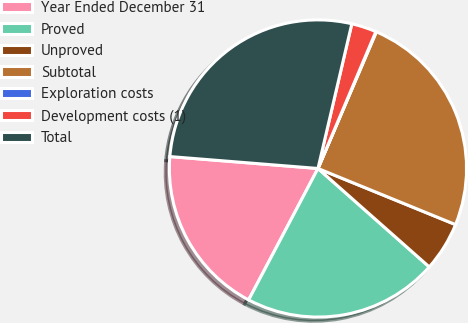<chart> <loc_0><loc_0><loc_500><loc_500><pie_chart><fcel>Year Ended December 31<fcel>Proved<fcel>Unproved<fcel>Subtotal<fcel>Exploration costs<fcel>Development costs (1)<fcel>Total<nl><fcel>18.55%<fcel>21.2%<fcel>5.36%<fcel>24.74%<fcel>0.06%<fcel>2.71%<fcel>27.38%<nl></chart> 